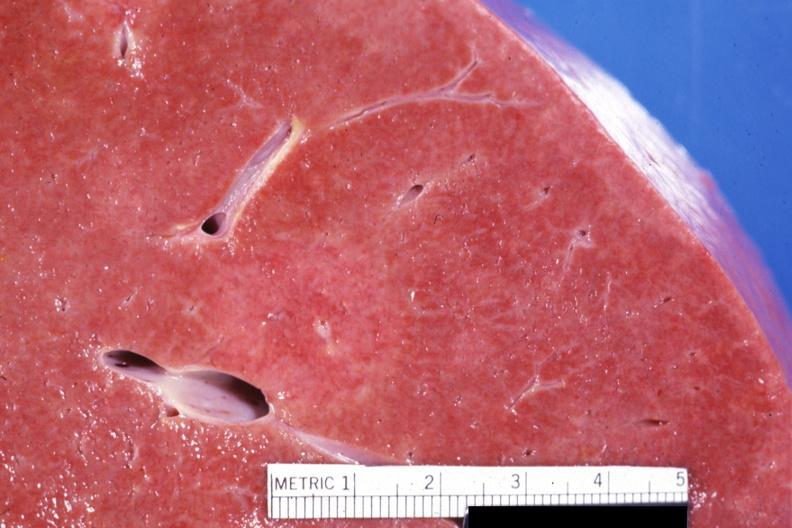s abdomen present?
Answer the question using a single word or phrase. No 